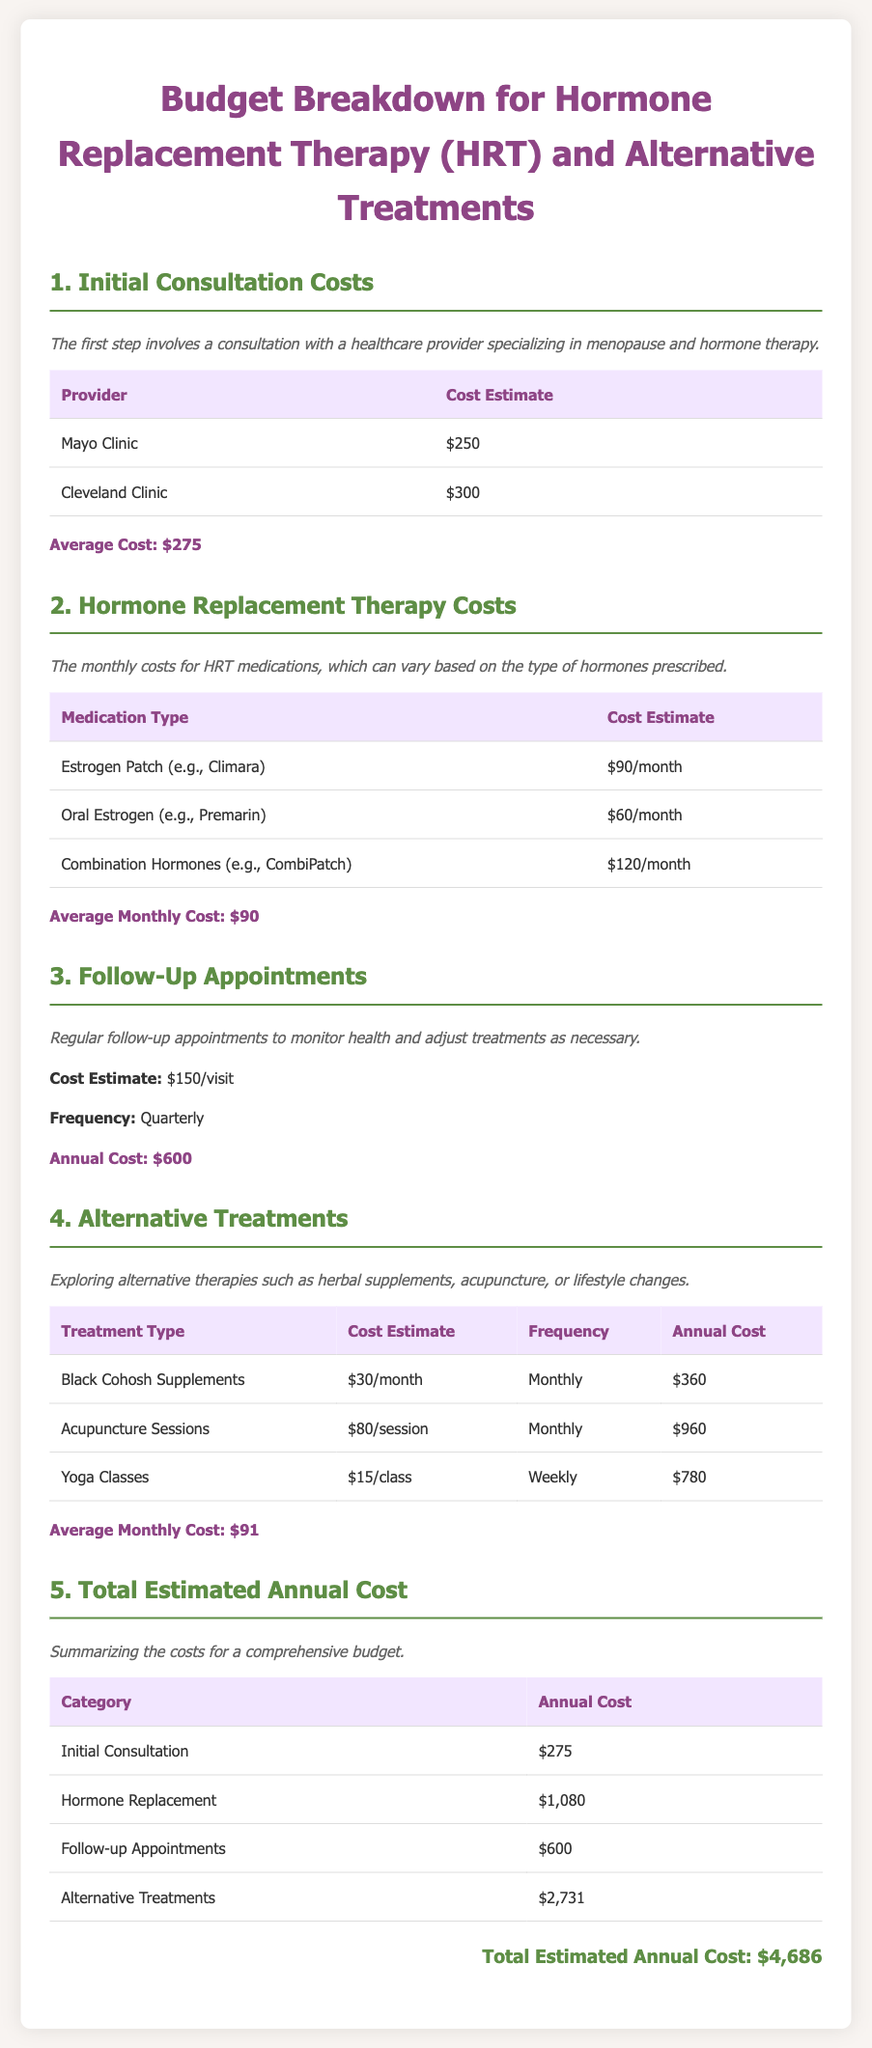What is the average cost of an initial consultation? The average cost is provided in the document as $275 based on the estimates given for different providers.
Answer: $275 What is the monthly cost of the estrogen patch? The document lists the cost of the estrogen patch (e.g., Climara) as $90 per month.
Answer: $90/month How much do follow-up appointments cost annually? The document states that follow-up appointments cost $150 each and are held quarterly, leading to an annual cost of $600.
Answer: $600 What is the total estimated annual cost for hormone replacement therapy? The total is derived from the costs mentioned in the document, including initial consultation, HRT, follow-ups, and alternatives, which totals $4,686.
Answer: $4,686 How much do yoga classes cost annually? The document indicates that yoga classes cost $15 per session and are weekly, resulting in an annual cost of $780.
Answer: $780 What is the total cost for alternative treatments? The document lists the total annual cost for alternative treatments as $2,731.
Answer: $2,731 What is the frequency of follow-up appointments? The document specifies that follow-up appointments occur quarterly.
Answer: Quarterly What is the cost of acupuncture sessions? According to the document, acupuncture sessions cost $80 each.
Answer: $80/session 